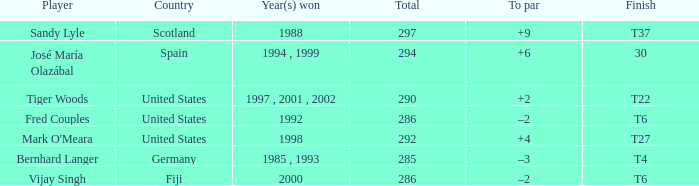What is the total for Bernhard Langer? 1.0. 